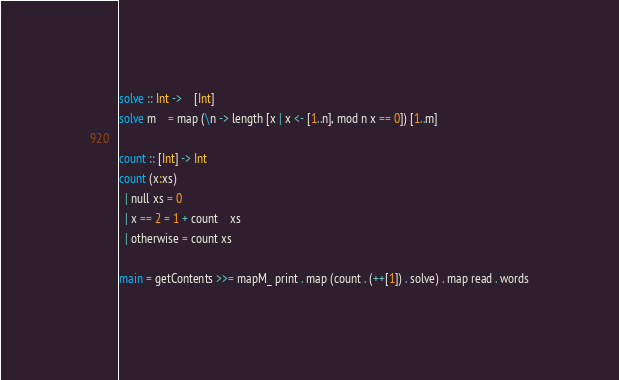<code> <loc_0><loc_0><loc_500><loc_500><_Haskell_>solve :: Int ->	[Int]
solve m	= map (\n -> length [x | x <- [1..n], mod n x == 0]) [1..m]

count :: [Int] -> Int
count (x:xs)
  | null xs = 0
  | x == 2 = 1 + count	xs
  | otherwise = count xs

main = getContents >>= mapM_ print . map (count . (++[1]) . solve) . map read . words</code> 